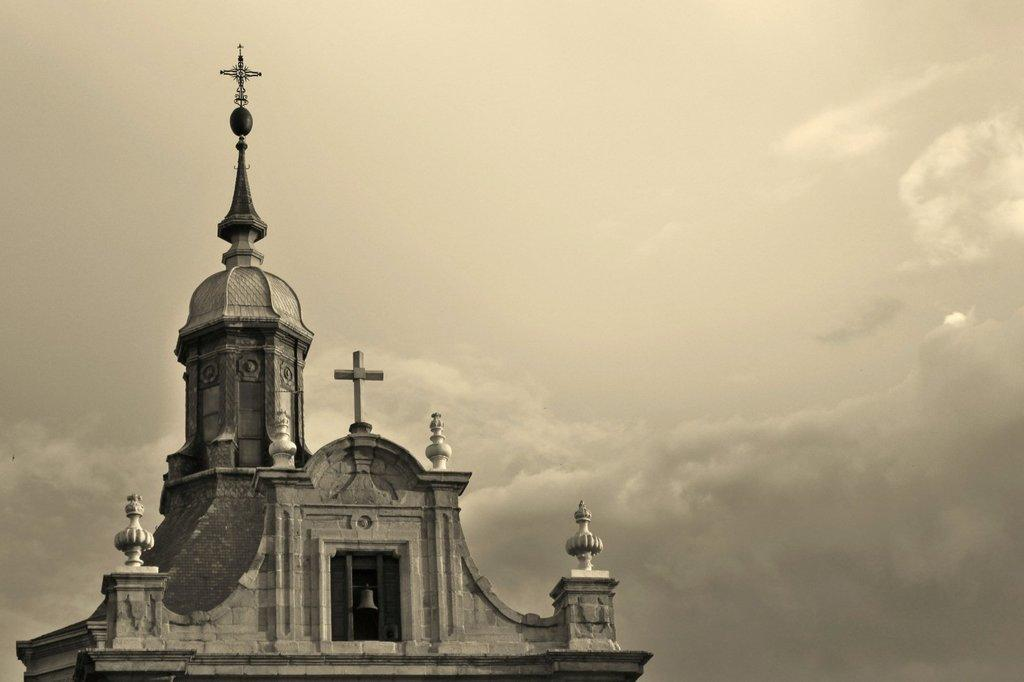What type of building is depicted in the picture? The picture shows the roof of a church. What can be seen at the center of the roof? There is a bell at the middle of the roof. How many eggs are present on the roof of the church in the image? There are no eggs present on the roof of the church in the image. 